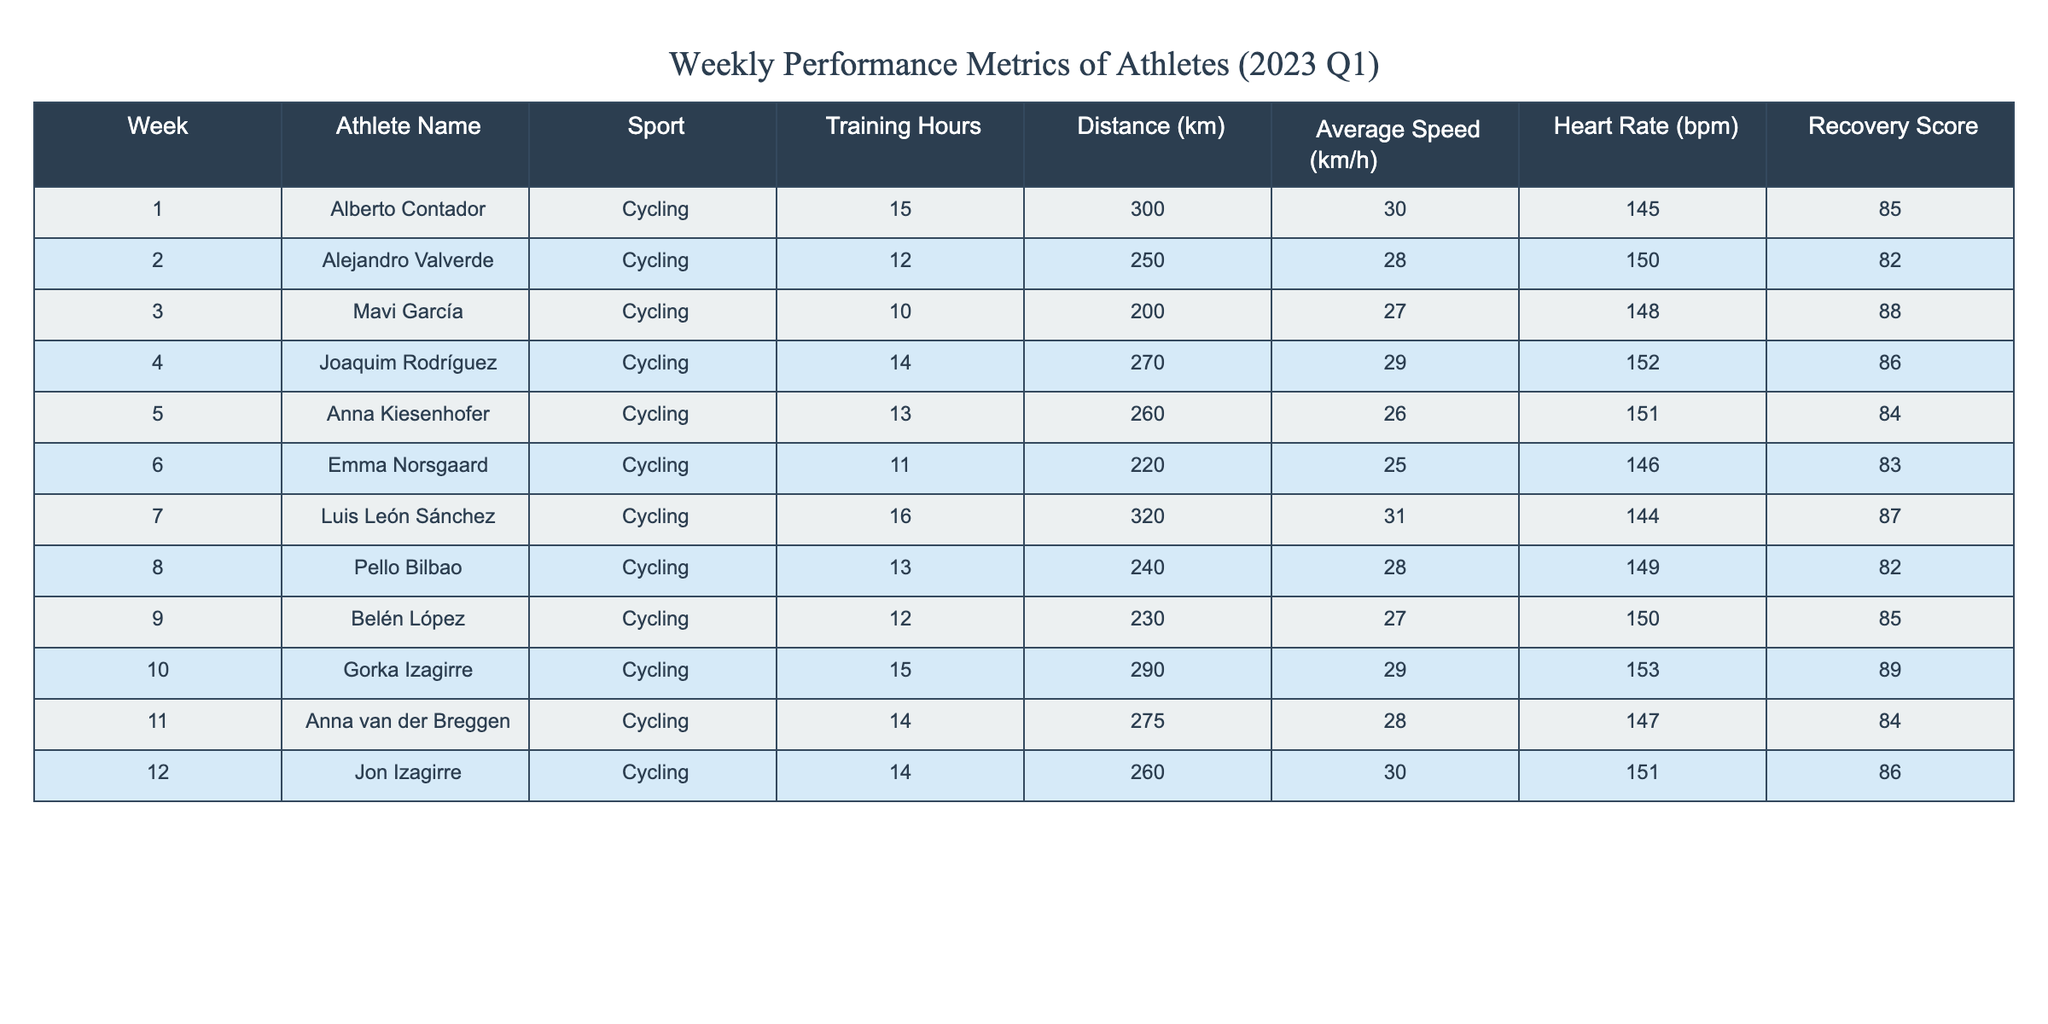What was the maximum distance covered by an athlete in week 7? In week 7, Luis León Sánchez covered a distance of 320 km, which is the highest noted in the table across all weeks.
Answer: 320 km Which athlete had the highest training hours in the first quarter? Luis León Sánchez had the highest training hours with a total of 16 hours in week 7.
Answer: 16 hours What is the average recovery score for all athletes? To find the average recovery score, we add all the recovery scores together (85 + 82 + 88 + 86 + 84 + 83 + 87 + 82 + 85 + 89 + 84 + 86) which equals 1024. There are 12 athletes, so we divide 1024 by 12, resulting in an average of 85.33.
Answer: 85.33 Did Mavi García have a higher average speed than Anna Kiesenhofer? Mavi García had an average speed of 27 km/h while Anna Kiesenhofer had an average speed of 26 km/h, so yes, Mavi García was faster.
Answer: Yes Which athlete had the lowest heart rate recorded and what was it? Emma Norsgaard had the lowest heart rate at 146 bpm.
Answer: 146 bpm What was the total distance covered by Joaquim Rodríguez and Gorka Izagirre combined? Joaquim Rodríguez covered 270 km and Gorka Izagirre covered 290 km. Adding these values together gives 270 + 290 = 560 km combined.
Answer: 560 km Is it true that the average training hours for the athletes is less than 15 hours? The average training hours can be calculated by adding all training hours (15 + 12 + 10 + 14 + 13 + 11 + 16 + 13 + 12 + 15 + 14 + 14) which totals  168 hours. Dividing 168 by 12 gives an average of 14 hours, hence it is false that the average is less than 15 hours.
Answer: No Which athlete achieved the highest average speed and what was it? Gorka Izagirre achieved the highest average speed of 29 km/h among all athletes noted in the table.
Answer: 29 km/h 